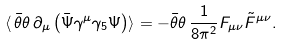<formula> <loc_0><loc_0><loc_500><loc_500>\langle \, \bar { \theta } \theta \, \partial _ { \mu } \left ( \bar { \Psi } \gamma ^ { \mu } \gamma _ { 5 } \Psi \right ) \rangle = - \bar { \theta } \theta \, \frac { 1 } { 8 \pi ^ { 2 } } F _ { \mu \nu } \tilde { F } ^ { \mu \nu } .</formula> 